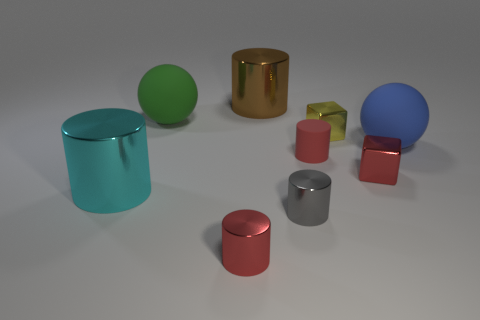Subtract all rubber cylinders. How many cylinders are left? 4 Add 1 gray metallic cylinders. How many objects exist? 10 Subtract all blocks. How many objects are left? 7 Subtract 4 cylinders. How many cylinders are left? 1 Subtract all yellow blocks. How many green spheres are left? 1 Subtract all cyan cylinders. How many cylinders are left? 4 Subtract all gray shiny things. Subtract all small red metallic blocks. How many objects are left? 7 Add 5 tiny red things. How many tiny red things are left? 8 Add 6 small yellow balls. How many small yellow balls exist? 6 Subtract 1 yellow blocks. How many objects are left? 8 